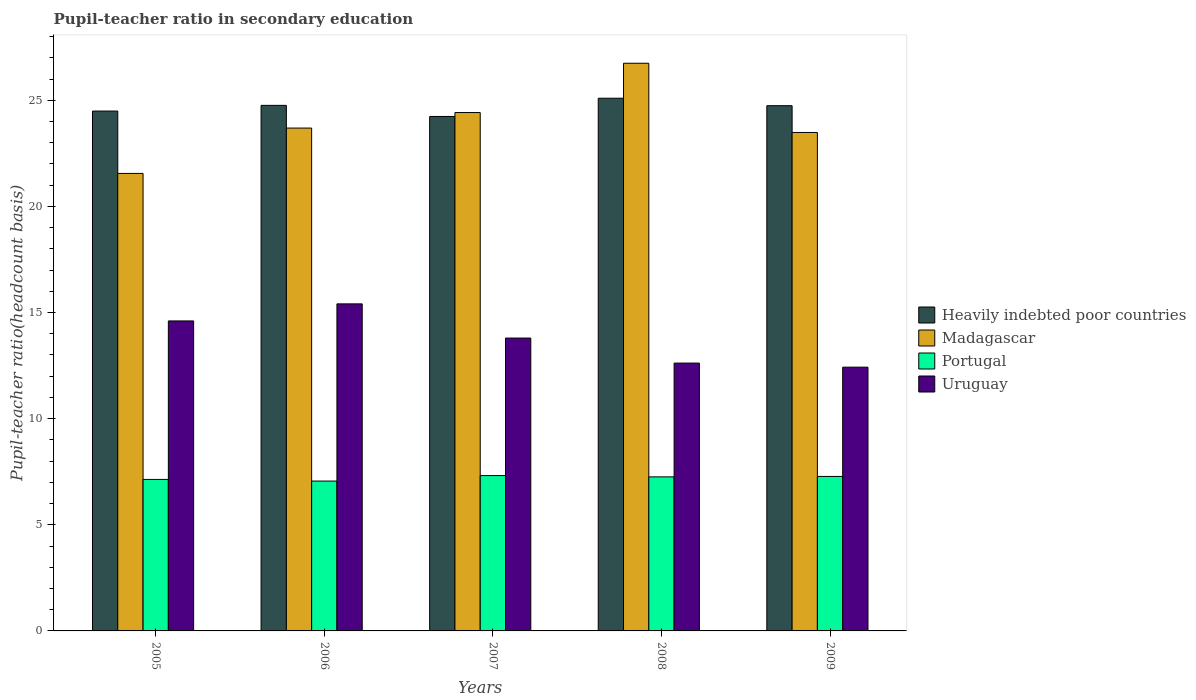How many bars are there on the 4th tick from the left?
Give a very brief answer. 4. How many bars are there on the 3rd tick from the right?
Ensure brevity in your answer.  4. What is the pupil-teacher ratio in secondary education in Madagascar in 2006?
Your response must be concise. 23.69. Across all years, what is the maximum pupil-teacher ratio in secondary education in Portugal?
Provide a short and direct response. 7.32. Across all years, what is the minimum pupil-teacher ratio in secondary education in Portugal?
Give a very brief answer. 7.06. In which year was the pupil-teacher ratio in secondary education in Portugal maximum?
Offer a very short reply. 2007. In which year was the pupil-teacher ratio in secondary education in Portugal minimum?
Your answer should be very brief. 2006. What is the total pupil-teacher ratio in secondary education in Uruguay in the graph?
Provide a short and direct response. 68.86. What is the difference between the pupil-teacher ratio in secondary education in Madagascar in 2007 and that in 2009?
Keep it short and to the point. 0.94. What is the difference between the pupil-teacher ratio in secondary education in Madagascar in 2008 and the pupil-teacher ratio in secondary education in Portugal in 2009?
Offer a very short reply. 19.47. What is the average pupil-teacher ratio in secondary education in Portugal per year?
Provide a succinct answer. 7.21. In the year 2007, what is the difference between the pupil-teacher ratio in secondary education in Uruguay and pupil-teacher ratio in secondary education in Portugal?
Provide a short and direct response. 6.48. What is the ratio of the pupil-teacher ratio in secondary education in Heavily indebted poor countries in 2006 to that in 2009?
Provide a short and direct response. 1. Is the difference between the pupil-teacher ratio in secondary education in Uruguay in 2005 and 2008 greater than the difference between the pupil-teacher ratio in secondary education in Portugal in 2005 and 2008?
Make the answer very short. Yes. What is the difference between the highest and the second highest pupil-teacher ratio in secondary education in Heavily indebted poor countries?
Ensure brevity in your answer.  0.34. What is the difference between the highest and the lowest pupil-teacher ratio in secondary education in Uruguay?
Provide a succinct answer. 2.98. In how many years, is the pupil-teacher ratio in secondary education in Madagascar greater than the average pupil-teacher ratio in secondary education in Madagascar taken over all years?
Make the answer very short. 2. Is it the case that in every year, the sum of the pupil-teacher ratio in secondary education in Portugal and pupil-teacher ratio in secondary education in Madagascar is greater than the sum of pupil-teacher ratio in secondary education in Uruguay and pupil-teacher ratio in secondary education in Heavily indebted poor countries?
Your response must be concise. Yes. What does the 4th bar from the left in 2006 represents?
Give a very brief answer. Uruguay. How many bars are there?
Keep it short and to the point. 20. How many years are there in the graph?
Your answer should be compact. 5. Are the values on the major ticks of Y-axis written in scientific E-notation?
Provide a succinct answer. No. Where does the legend appear in the graph?
Give a very brief answer. Center right. How many legend labels are there?
Make the answer very short. 4. How are the legend labels stacked?
Your answer should be very brief. Vertical. What is the title of the graph?
Your response must be concise. Pupil-teacher ratio in secondary education. What is the label or title of the Y-axis?
Ensure brevity in your answer.  Pupil-teacher ratio(headcount basis). What is the Pupil-teacher ratio(headcount basis) in Heavily indebted poor countries in 2005?
Your answer should be compact. 24.49. What is the Pupil-teacher ratio(headcount basis) of Madagascar in 2005?
Provide a succinct answer. 21.56. What is the Pupil-teacher ratio(headcount basis) of Portugal in 2005?
Provide a succinct answer. 7.14. What is the Pupil-teacher ratio(headcount basis) in Uruguay in 2005?
Provide a short and direct response. 14.6. What is the Pupil-teacher ratio(headcount basis) in Heavily indebted poor countries in 2006?
Make the answer very short. 24.76. What is the Pupil-teacher ratio(headcount basis) of Madagascar in 2006?
Offer a very short reply. 23.69. What is the Pupil-teacher ratio(headcount basis) in Portugal in 2006?
Your response must be concise. 7.06. What is the Pupil-teacher ratio(headcount basis) of Uruguay in 2006?
Make the answer very short. 15.41. What is the Pupil-teacher ratio(headcount basis) of Heavily indebted poor countries in 2007?
Make the answer very short. 24.24. What is the Pupil-teacher ratio(headcount basis) of Madagascar in 2007?
Your answer should be compact. 24.42. What is the Pupil-teacher ratio(headcount basis) in Portugal in 2007?
Offer a very short reply. 7.32. What is the Pupil-teacher ratio(headcount basis) of Uruguay in 2007?
Your answer should be very brief. 13.8. What is the Pupil-teacher ratio(headcount basis) of Heavily indebted poor countries in 2008?
Give a very brief answer. 25.1. What is the Pupil-teacher ratio(headcount basis) in Madagascar in 2008?
Give a very brief answer. 26.74. What is the Pupil-teacher ratio(headcount basis) in Portugal in 2008?
Your answer should be compact. 7.26. What is the Pupil-teacher ratio(headcount basis) in Uruguay in 2008?
Give a very brief answer. 12.62. What is the Pupil-teacher ratio(headcount basis) in Heavily indebted poor countries in 2009?
Provide a short and direct response. 24.75. What is the Pupil-teacher ratio(headcount basis) in Madagascar in 2009?
Keep it short and to the point. 23.48. What is the Pupil-teacher ratio(headcount basis) of Portugal in 2009?
Make the answer very short. 7.28. What is the Pupil-teacher ratio(headcount basis) of Uruguay in 2009?
Your response must be concise. 12.43. Across all years, what is the maximum Pupil-teacher ratio(headcount basis) in Heavily indebted poor countries?
Ensure brevity in your answer.  25.1. Across all years, what is the maximum Pupil-teacher ratio(headcount basis) in Madagascar?
Give a very brief answer. 26.74. Across all years, what is the maximum Pupil-teacher ratio(headcount basis) in Portugal?
Your response must be concise. 7.32. Across all years, what is the maximum Pupil-teacher ratio(headcount basis) in Uruguay?
Your answer should be very brief. 15.41. Across all years, what is the minimum Pupil-teacher ratio(headcount basis) in Heavily indebted poor countries?
Your response must be concise. 24.24. Across all years, what is the minimum Pupil-teacher ratio(headcount basis) of Madagascar?
Ensure brevity in your answer.  21.56. Across all years, what is the minimum Pupil-teacher ratio(headcount basis) of Portugal?
Keep it short and to the point. 7.06. Across all years, what is the minimum Pupil-teacher ratio(headcount basis) in Uruguay?
Give a very brief answer. 12.43. What is the total Pupil-teacher ratio(headcount basis) of Heavily indebted poor countries in the graph?
Your answer should be very brief. 123.33. What is the total Pupil-teacher ratio(headcount basis) in Madagascar in the graph?
Your answer should be very brief. 119.9. What is the total Pupil-teacher ratio(headcount basis) of Portugal in the graph?
Make the answer very short. 36.05. What is the total Pupil-teacher ratio(headcount basis) in Uruguay in the graph?
Keep it short and to the point. 68.86. What is the difference between the Pupil-teacher ratio(headcount basis) of Heavily indebted poor countries in 2005 and that in 2006?
Offer a very short reply. -0.27. What is the difference between the Pupil-teacher ratio(headcount basis) in Madagascar in 2005 and that in 2006?
Ensure brevity in your answer.  -2.14. What is the difference between the Pupil-teacher ratio(headcount basis) in Portugal in 2005 and that in 2006?
Keep it short and to the point. 0.08. What is the difference between the Pupil-teacher ratio(headcount basis) in Uruguay in 2005 and that in 2006?
Make the answer very short. -0.8. What is the difference between the Pupil-teacher ratio(headcount basis) in Heavily indebted poor countries in 2005 and that in 2007?
Offer a very short reply. 0.25. What is the difference between the Pupil-teacher ratio(headcount basis) of Madagascar in 2005 and that in 2007?
Offer a terse response. -2.87. What is the difference between the Pupil-teacher ratio(headcount basis) of Portugal in 2005 and that in 2007?
Your response must be concise. -0.18. What is the difference between the Pupil-teacher ratio(headcount basis) in Uruguay in 2005 and that in 2007?
Provide a succinct answer. 0.81. What is the difference between the Pupil-teacher ratio(headcount basis) of Heavily indebted poor countries in 2005 and that in 2008?
Ensure brevity in your answer.  -0.6. What is the difference between the Pupil-teacher ratio(headcount basis) of Madagascar in 2005 and that in 2008?
Provide a short and direct response. -5.19. What is the difference between the Pupil-teacher ratio(headcount basis) in Portugal in 2005 and that in 2008?
Your answer should be compact. -0.12. What is the difference between the Pupil-teacher ratio(headcount basis) of Uruguay in 2005 and that in 2008?
Your answer should be very brief. 1.99. What is the difference between the Pupil-teacher ratio(headcount basis) of Heavily indebted poor countries in 2005 and that in 2009?
Ensure brevity in your answer.  -0.25. What is the difference between the Pupil-teacher ratio(headcount basis) in Madagascar in 2005 and that in 2009?
Offer a terse response. -1.93. What is the difference between the Pupil-teacher ratio(headcount basis) of Portugal in 2005 and that in 2009?
Your answer should be compact. -0.14. What is the difference between the Pupil-teacher ratio(headcount basis) of Uruguay in 2005 and that in 2009?
Your response must be concise. 2.18. What is the difference between the Pupil-teacher ratio(headcount basis) in Heavily indebted poor countries in 2006 and that in 2007?
Keep it short and to the point. 0.52. What is the difference between the Pupil-teacher ratio(headcount basis) of Madagascar in 2006 and that in 2007?
Provide a succinct answer. -0.73. What is the difference between the Pupil-teacher ratio(headcount basis) in Portugal in 2006 and that in 2007?
Your answer should be compact. -0.26. What is the difference between the Pupil-teacher ratio(headcount basis) in Uruguay in 2006 and that in 2007?
Your answer should be compact. 1.61. What is the difference between the Pupil-teacher ratio(headcount basis) of Heavily indebted poor countries in 2006 and that in 2008?
Offer a terse response. -0.34. What is the difference between the Pupil-teacher ratio(headcount basis) in Madagascar in 2006 and that in 2008?
Keep it short and to the point. -3.05. What is the difference between the Pupil-teacher ratio(headcount basis) in Portugal in 2006 and that in 2008?
Offer a very short reply. -0.2. What is the difference between the Pupil-teacher ratio(headcount basis) in Uruguay in 2006 and that in 2008?
Your answer should be very brief. 2.79. What is the difference between the Pupil-teacher ratio(headcount basis) of Heavily indebted poor countries in 2006 and that in 2009?
Make the answer very short. 0.02. What is the difference between the Pupil-teacher ratio(headcount basis) in Madagascar in 2006 and that in 2009?
Provide a short and direct response. 0.21. What is the difference between the Pupil-teacher ratio(headcount basis) of Portugal in 2006 and that in 2009?
Offer a very short reply. -0.22. What is the difference between the Pupil-teacher ratio(headcount basis) in Uruguay in 2006 and that in 2009?
Your answer should be very brief. 2.98. What is the difference between the Pupil-teacher ratio(headcount basis) in Heavily indebted poor countries in 2007 and that in 2008?
Keep it short and to the point. -0.86. What is the difference between the Pupil-teacher ratio(headcount basis) in Madagascar in 2007 and that in 2008?
Offer a very short reply. -2.32. What is the difference between the Pupil-teacher ratio(headcount basis) in Portugal in 2007 and that in 2008?
Offer a terse response. 0.06. What is the difference between the Pupil-teacher ratio(headcount basis) of Uruguay in 2007 and that in 2008?
Provide a short and direct response. 1.18. What is the difference between the Pupil-teacher ratio(headcount basis) of Heavily indebted poor countries in 2007 and that in 2009?
Your response must be concise. -0.51. What is the difference between the Pupil-teacher ratio(headcount basis) of Madagascar in 2007 and that in 2009?
Provide a short and direct response. 0.94. What is the difference between the Pupil-teacher ratio(headcount basis) of Portugal in 2007 and that in 2009?
Provide a short and direct response. 0.04. What is the difference between the Pupil-teacher ratio(headcount basis) of Uruguay in 2007 and that in 2009?
Make the answer very short. 1.37. What is the difference between the Pupil-teacher ratio(headcount basis) of Heavily indebted poor countries in 2008 and that in 2009?
Your response must be concise. 0.35. What is the difference between the Pupil-teacher ratio(headcount basis) in Madagascar in 2008 and that in 2009?
Your answer should be very brief. 3.26. What is the difference between the Pupil-teacher ratio(headcount basis) of Portugal in 2008 and that in 2009?
Keep it short and to the point. -0.02. What is the difference between the Pupil-teacher ratio(headcount basis) of Uruguay in 2008 and that in 2009?
Your answer should be very brief. 0.19. What is the difference between the Pupil-teacher ratio(headcount basis) of Heavily indebted poor countries in 2005 and the Pupil-teacher ratio(headcount basis) of Madagascar in 2006?
Give a very brief answer. 0.8. What is the difference between the Pupil-teacher ratio(headcount basis) in Heavily indebted poor countries in 2005 and the Pupil-teacher ratio(headcount basis) in Portugal in 2006?
Ensure brevity in your answer.  17.43. What is the difference between the Pupil-teacher ratio(headcount basis) of Heavily indebted poor countries in 2005 and the Pupil-teacher ratio(headcount basis) of Uruguay in 2006?
Ensure brevity in your answer.  9.08. What is the difference between the Pupil-teacher ratio(headcount basis) of Madagascar in 2005 and the Pupil-teacher ratio(headcount basis) of Portugal in 2006?
Make the answer very short. 14.49. What is the difference between the Pupil-teacher ratio(headcount basis) in Madagascar in 2005 and the Pupil-teacher ratio(headcount basis) in Uruguay in 2006?
Ensure brevity in your answer.  6.15. What is the difference between the Pupil-teacher ratio(headcount basis) in Portugal in 2005 and the Pupil-teacher ratio(headcount basis) in Uruguay in 2006?
Provide a short and direct response. -8.27. What is the difference between the Pupil-teacher ratio(headcount basis) in Heavily indebted poor countries in 2005 and the Pupil-teacher ratio(headcount basis) in Madagascar in 2007?
Give a very brief answer. 0.07. What is the difference between the Pupil-teacher ratio(headcount basis) in Heavily indebted poor countries in 2005 and the Pupil-teacher ratio(headcount basis) in Portugal in 2007?
Your answer should be compact. 17.17. What is the difference between the Pupil-teacher ratio(headcount basis) of Heavily indebted poor countries in 2005 and the Pupil-teacher ratio(headcount basis) of Uruguay in 2007?
Ensure brevity in your answer.  10.69. What is the difference between the Pupil-teacher ratio(headcount basis) in Madagascar in 2005 and the Pupil-teacher ratio(headcount basis) in Portugal in 2007?
Make the answer very short. 14.24. What is the difference between the Pupil-teacher ratio(headcount basis) in Madagascar in 2005 and the Pupil-teacher ratio(headcount basis) in Uruguay in 2007?
Offer a very short reply. 7.76. What is the difference between the Pupil-teacher ratio(headcount basis) of Portugal in 2005 and the Pupil-teacher ratio(headcount basis) of Uruguay in 2007?
Offer a terse response. -6.66. What is the difference between the Pupil-teacher ratio(headcount basis) in Heavily indebted poor countries in 2005 and the Pupil-teacher ratio(headcount basis) in Madagascar in 2008?
Your response must be concise. -2.25. What is the difference between the Pupil-teacher ratio(headcount basis) of Heavily indebted poor countries in 2005 and the Pupil-teacher ratio(headcount basis) of Portugal in 2008?
Ensure brevity in your answer.  17.23. What is the difference between the Pupil-teacher ratio(headcount basis) in Heavily indebted poor countries in 2005 and the Pupil-teacher ratio(headcount basis) in Uruguay in 2008?
Keep it short and to the point. 11.87. What is the difference between the Pupil-teacher ratio(headcount basis) of Madagascar in 2005 and the Pupil-teacher ratio(headcount basis) of Portugal in 2008?
Give a very brief answer. 14.3. What is the difference between the Pupil-teacher ratio(headcount basis) of Madagascar in 2005 and the Pupil-teacher ratio(headcount basis) of Uruguay in 2008?
Offer a terse response. 8.94. What is the difference between the Pupil-teacher ratio(headcount basis) in Portugal in 2005 and the Pupil-teacher ratio(headcount basis) in Uruguay in 2008?
Provide a short and direct response. -5.48. What is the difference between the Pupil-teacher ratio(headcount basis) in Heavily indebted poor countries in 2005 and the Pupil-teacher ratio(headcount basis) in Madagascar in 2009?
Provide a short and direct response. 1.01. What is the difference between the Pupil-teacher ratio(headcount basis) of Heavily indebted poor countries in 2005 and the Pupil-teacher ratio(headcount basis) of Portugal in 2009?
Your answer should be very brief. 17.21. What is the difference between the Pupil-teacher ratio(headcount basis) in Heavily indebted poor countries in 2005 and the Pupil-teacher ratio(headcount basis) in Uruguay in 2009?
Make the answer very short. 12.07. What is the difference between the Pupil-teacher ratio(headcount basis) in Madagascar in 2005 and the Pupil-teacher ratio(headcount basis) in Portugal in 2009?
Give a very brief answer. 14.28. What is the difference between the Pupil-teacher ratio(headcount basis) in Madagascar in 2005 and the Pupil-teacher ratio(headcount basis) in Uruguay in 2009?
Provide a short and direct response. 9.13. What is the difference between the Pupil-teacher ratio(headcount basis) of Portugal in 2005 and the Pupil-teacher ratio(headcount basis) of Uruguay in 2009?
Offer a very short reply. -5.29. What is the difference between the Pupil-teacher ratio(headcount basis) of Heavily indebted poor countries in 2006 and the Pupil-teacher ratio(headcount basis) of Madagascar in 2007?
Give a very brief answer. 0.34. What is the difference between the Pupil-teacher ratio(headcount basis) in Heavily indebted poor countries in 2006 and the Pupil-teacher ratio(headcount basis) in Portugal in 2007?
Your answer should be very brief. 17.44. What is the difference between the Pupil-teacher ratio(headcount basis) of Heavily indebted poor countries in 2006 and the Pupil-teacher ratio(headcount basis) of Uruguay in 2007?
Your response must be concise. 10.96. What is the difference between the Pupil-teacher ratio(headcount basis) in Madagascar in 2006 and the Pupil-teacher ratio(headcount basis) in Portugal in 2007?
Provide a succinct answer. 16.37. What is the difference between the Pupil-teacher ratio(headcount basis) of Madagascar in 2006 and the Pupil-teacher ratio(headcount basis) of Uruguay in 2007?
Offer a very short reply. 9.89. What is the difference between the Pupil-teacher ratio(headcount basis) in Portugal in 2006 and the Pupil-teacher ratio(headcount basis) in Uruguay in 2007?
Provide a short and direct response. -6.74. What is the difference between the Pupil-teacher ratio(headcount basis) in Heavily indebted poor countries in 2006 and the Pupil-teacher ratio(headcount basis) in Madagascar in 2008?
Your answer should be compact. -1.98. What is the difference between the Pupil-teacher ratio(headcount basis) of Heavily indebted poor countries in 2006 and the Pupil-teacher ratio(headcount basis) of Portugal in 2008?
Provide a short and direct response. 17.5. What is the difference between the Pupil-teacher ratio(headcount basis) of Heavily indebted poor countries in 2006 and the Pupil-teacher ratio(headcount basis) of Uruguay in 2008?
Offer a terse response. 12.14. What is the difference between the Pupil-teacher ratio(headcount basis) in Madagascar in 2006 and the Pupil-teacher ratio(headcount basis) in Portugal in 2008?
Give a very brief answer. 16.43. What is the difference between the Pupil-teacher ratio(headcount basis) in Madagascar in 2006 and the Pupil-teacher ratio(headcount basis) in Uruguay in 2008?
Ensure brevity in your answer.  11.07. What is the difference between the Pupil-teacher ratio(headcount basis) of Portugal in 2006 and the Pupil-teacher ratio(headcount basis) of Uruguay in 2008?
Ensure brevity in your answer.  -5.56. What is the difference between the Pupil-teacher ratio(headcount basis) of Heavily indebted poor countries in 2006 and the Pupil-teacher ratio(headcount basis) of Madagascar in 2009?
Provide a succinct answer. 1.28. What is the difference between the Pupil-teacher ratio(headcount basis) of Heavily indebted poor countries in 2006 and the Pupil-teacher ratio(headcount basis) of Portugal in 2009?
Your response must be concise. 17.48. What is the difference between the Pupil-teacher ratio(headcount basis) in Heavily indebted poor countries in 2006 and the Pupil-teacher ratio(headcount basis) in Uruguay in 2009?
Give a very brief answer. 12.33. What is the difference between the Pupil-teacher ratio(headcount basis) of Madagascar in 2006 and the Pupil-teacher ratio(headcount basis) of Portugal in 2009?
Your answer should be very brief. 16.41. What is the difference between the Pupil-teacher ratio(headcount basis) of Madagascar in 2006 and the Pupil-teacher ratio(headcount basis) of Uruguay in 2009?
Offer a terse response. 11.27. What is the difference between the Pupil-teacher ratio(headcount basis) in Portugal in 2006 and the Pupil-teacher ratio(headcount basis) in Uruguay in 2009?
Offer a very short reply. -5.37. What is the difference between the Pupil-teacher ratio(headcount basis) in Heavily indebted poor countries in 2007 and the Pupil-teacher ratio(headcount basis) in Madagascar in 2008?
Your answer should be very brief. -2.51. What is the difference between the Pupil-teacher ratio(headcount basis) in Heavily indebted poor countries in 2007 and the Pupil-teacher ratio(headcount basis) in Portugal in 2008?
Provide a short and direct response. 16.98. What is the difference between the Pupil-teacher ratio(headcount basis) of Heavily indebted poor countries in 2007 and the Pupil-teacher ratio(headcount basis) of Uruguay in 2008?
Keep it short and to the point. 11.62. What is the difference between the Pupil-teacher ratio(headcount basis) in Madagascar in 2007 and the Pupil-teacher ratio(headcount basis) in Portugal in 2008?
Offer a terse response. 17.16. What is the difference between the Pupil-teacher ratio(headcount basis) of Madagascar in 2007 and the Pupil-teacher ratio(headcount basis) of Uruguay in 2008?
Your answer should be very brief. 11.8. What is the difference between the Pupil-teacher ratio(headcount basis) of Portugal in 2007 and the Pupil-teacher ratio(headcount basis) of Uruguay in 2008?
Your response must be concise. -5.3. What is the difference between the Pupil-teacher ratio(headcount basis) of Heavily indebted poor countries in 2007 and the Pupil-teacher ratio(headcount basis) of Madagascar in 2009?
Provide a succinct answer. 0.75. What is the difference between the Pupil-teacher ratio(headcount basis) in Heavily indebted poor countries in 2007 and the Pupil-teacher ratio(headcount basis) in Portugal in 2009?
Give a very brief answer. 16.96. What is the difference between the Pupil-teacher ratio(headcount basis) in Heavily indebted poor countries in 2007 and the Pupil-teacher ratio(headcount basis) in Uruguay in 2009?
Offer a very short reply. 11.81. What is the difference between the Pupil-teacher ratio(headcount basis) in Madagascar in 2007 and the Pupil-teacher ratio(headcount basis) in Portugal in 2009?
Your response must be concise. 17.15. What is the difference between the Pupil-teacher ratio(headcount basis) of Madagascar in 2007 and the Pupil-teacher ratio(headcount basis) of Uruguay in 2009?
Keep it short and to the point. 12. What is the difference between the Pupil-teacher ratio(headcount basis) in Portugal in 2007 and the Pupil-teacher ratio(headcount basis) in Uruguay in 2009?
Make the answer very short. -5.11. What is the difference between the Pupil-teacher ratio(headcount basis) of Heavily indebted poor countries in 2008 and the Pupil-teacher ratio(headcount basis) of Madagascar in 2009?
Provide a succinct answer. 1.61. What is the difference between the Pupil-teacher ratio(headcount basis) in Heavily indebted poor countries in 2008 and the Pupil-teacher ratio(headcount basis) in Portugal in 2009?
Ensure brevity in your answer.  17.82. What is the difference between the Pupil-teacher ratio(headcount basis) of Heavily indebted poor countries in 2008 and the Pupil-teacher ratio(headcount basis) of Uruguay in 2009?
Your response must be concise. 12.67. What is the difference between the Pupil-teacher ratio(headcount basis) of Madagascar in 2008 and the Pupil-teacher ratio(headcount basis) of Portugal in 2009?
Offer a very short reply. 19.47. What is the difference between the Pupil-teacher ratio(headcount basis) in Madagascar in 2008 and the Pupil-teacher ratio(headcount basis) in Uruguay in 2009?
Your answer should be compact. 14.32. What is the difference between the Pupil-teacher ratio(headcount basis) in Portugal in 2008 and the Pupil-teacher ratio(headcount basis) in Uruguay in 2009?
Your answer should be compact. -5.17. What is the average Pupil-teacher ratio(headcount basis) in Heavily indebted poor countries per year?
Offer a terse response. 24.67. What is the average Pupil-teacher ratio(headcount basis) of Madagascar per year?
Your answer should be compact. 23.98. What is the average Pupil-teacher ratio(headcount basis) of Portugal per year?
Ensure brevity in your answer.  7.21. What is the average Pupil-teacher ratio(headcount basis) of Uruguay per year?
Offer a terse response. 13.77. In the year 2005, what is the difference between the Pupil-teacher ratio(headcount basis) in Heavily indebted poor countries and Pupil-teacher ratio(headcount basis) in Madagascar?
Your answer should be compact. 2.94. In the year 2005, what is the difference between the Pupil-teacher ratio(headcount basis) in Heavily indebted poor countries and Pupil-teacher ratio(headcount basis) in Portugal?
Provide a short and direct response. 17.36. In the year 2005, what is the difference between the Pupil-teacher ratio(headcount basis) in Heavily indebted poor countries and Pupil-teacher ratio(headcount basis) in Uruguay?
Offer a terse response. 9.89. In the year 2005, what is the difference between the Pupil-teacher ratio(headcount basis) in Madagascar and Pupil-teacher ratio(headcount basis) in Portugal?
Offer a terse response. 14.42. In the year 2005, what is the difference between the Pupil-teacher ratio(headcount basis) of Madagascar and Pupil-teacher ratio(headcount basis) of Uruguay?
Your answer should be very brief. 6.95. In the year 2005, what is the difference between the Pupil-teacher ratio(headcount basis) in Portugal and Pupil-teacher ratio(headcount basis) in Uruguay?
Your response must be concise. -7.47. In the year 2006, what is the difference between the Pupil-teacher ratio(headcount basis) in Heavily indebted poor countries and Pupil-teacher ratio(headcount basis) in Madagascar?
Keep it short and to the point. 1.07. In the year 2006, what is the difference between the Pupil-teacher ratio(headcount basis) in Heavily indebted poor countries and Pupil-teacher ratio(headcount basis) in Portugal?
Your response must be concise. 17.7. In the year 2006, what is the difference between the Pupil-teacher ratio(headcount basis) of Heavily indebted poor countries and Pupil-teacher ratio(headcount basis) of Uruguay?
Provide a short and direct response. 9.35. In the year 2006, what is the difference between the Pupil-teacher ratio(headcount basis) of Madagascar and Pupil-teacher ratio(headcount basis) of Portugal?
Give a very brief answer. 16.63. In the year 2006, what is the difference between the Pupil-teacher ratio(headcount basis) in Madagascar and Pupil-teacher ratio(headcount basis) in Uruguay?
Keep it short and to the point. 8.28. In the year 2006, what is the difference between the Pupil-teacher ratio(headcount basis) of Portugal and Pupil-teacher ratio(headcount basis) of Uruguay?
Provide a short and direct response. -8.35. In the year 2007, what is the difference between the Pupil-teacher ratio(headcount basis) in Heavily indebted poor countries and Pupil-teacher ratio(headcount basis) in Madagascar?
Make the answer very short. -0.18. In the year 2007, what is the difference between the Pupil-teacher ratio(headcount basis) of Heavily indebted poor countries and Pupil-teacher ratio(headcount basis) of Portugal?
Provide a succinct answer. 16.92. In the year 2007, what is the difference between the Pupil-teacher ratio(headcount basis) of Heavily indebted poor countries and Pupil-teacher ratio(headcount basis) of Uruguay?
Your response must be concise. 10.44. In the year 2007, what is the difference between the Pupil-teacher ratio(headcount basis) in Madagascar and Pupil-teacher ratio(headcount basis) in Portugal?
Give a very brief answer. 17.11. In the year 2007, what is the difference between the Pupil-teacher ratio(headcount basis) of Madagascar and Pupil-teacher ratio(headcount basis) of Uruguay?
Your answer should be compact. 10.63. In the year 2007, what is the difference between the Pupil-teacher ratio(headcount basis) of Portugal and Pupil-teacher ratio(headcount basis) of Uruguay?
Provide a succinct answer. -6.48. In the year 2008, what is the difference between the Pupil-teacher ratio(headcount basis) of Heavily indebted poor countries and Pupil-teacher ratio(headcount basis) of Madagascar?
Offer a terse response. -1.65. In the year 2008, what is the difference between the Pupil-teacher ratio(headcount basis) of Heavily indebted poor countries and Pupil-teacher ratio(headcount basis) of Portugal?
Provide a short and direct response. 17.84. In the year 2008, what is the difference between the Pupil-teacher ratio(headcount basis) in Heavily indebted poor countries and Pupil-teacher ratio(headcount basis) in Uruguay?
Your answer should be compact. 12.48. In the year 2008, what is the difference between the Pupil-teacher ratio(headcount basis) in Madagascar and Pupil-teacher ratio(headcount basis) in Portugal?
Give a very brief answer. 19.49. In the year 2008, what is the difference between the Pupil-teacher ratio(headcount basis) of Madagascar and Pupil-teacher ratio(headcount basis) of Uruguay?
Ensure brevity in your answer.  14.13. In the year 2008, what is the difference between the Pupil-teacher ratio(headcount basis) in Portugal and Pupil-teacher ratio(headcount basis) in Uruguay?
Give a very brief answer. -5.36. In the year 2009, what is the difference between the Pupil-teacher ratio(headcount basis) in Heavily indebted poor countries and Pupil-teacher ratio(headcount basis) in Madagascar?
Give a very brief answer. 1.26. In the year 2009, what is the difference between the Pupil-teacher ratio(headcount basis) of Heavily indebted poor countries and Pupil-teacher ratio(headcount basis) of Portugal?
Give a very brief answer. 17.47. In the year 2009, what is the difference between the Pupil-teacher ratio(headcount basis) of Heavily indebted poor countries and Pupil-teacher ratio(headcount basis) of Uruguay?
Offer a very short reply. 12.32. In the year 2009, what is the difference between the Pupil-teacher ratio(headcount basis) of Madagascar and Pupil-teacher ratio(headcount basis) of Portugal?
Keep it short and to the point. 16.21. In the year 2009, what is the difference between the Pupil-teacher ratio(headcount basis) in Madagascar and Pupil-teacher ratio(headcount basis) in Uruguay?
Provide a succinct answer. 11.06. In the year 2009, what is the difference between the Pupil-teacher ratio(headcount basis) in Portugal and Pupil-teacher ratio(headcount basis) in Uruguay?
Make the answer very short. -5.15. What is the ratio of the Pupil-teacher ratio(headcount basis) in Madagascar in 2005 to that in 2006?
Offer a terse response. 0.91. What is the ratio of the Pupil-teacher ratio(headcount basis) in Portugal in 2005 to that in 2006?
Keep it short and to the point. 1.01. What is the ratio of the Pupil-teacher ratio(headcount basis) in Uruguay in 2005 to that in 2006?
Offer a very short reply. 0.95. What is the ratio of the Pupil-teacher ratio(headcount basis) in Heavily indebted poor countries in 2005 to that in 2007?
Keep it short and to the point. 1.01. What is the ratio of the Pupil-teacher ratio(headcount basis) of Madagascar in 2005 to that in 2007?
Your answer should be compact. 0.88. What is the ratio of the Pupil-teacher ratio(headcount basis) of Portugal in 2005 to that in 2007?
Provide a short and direct response. 0.98. What is the ratio of the Pupil-teacher ratio(headcount basis) of Uruguay in 2005 to that in 2007?
Provide a short and direct response. 1.06. What is the ratio of the Pupil-teacher ratio(headcount basis) in Heavily indebted poor countries in 2005 to that in 2008?
Your answer should be compact. 0.98. What is the ratio of the Pupil-teacher ratio(headcount basis) of Madagascar in 2005 to that in 2008?
Your response must be concise. 0.81. What is the ratio of the Pupil-teacher ratio(headcount basis) of Portugal in 2005 to that in 2008?
Make the answer very short. 0.98. What is the ratio of the Pupil-teacher ratio(headcount basis) in Uruguay in 2005 to that in 2008?
Your answer should be very brief. 1.16. What is the ratio of the Pupil-teacher ratio(headcount basis) of Heavily indebted poor countries in 2005 to that in 2009?
Your answer should be very brief. 0.99. What is the ratio of the Pupil-teacher ratio(headcount basis) of Madagascar in 2005 to that in 2009?
Your answer should be compact. 0.92. What is the ratio of the Pupil-teacher ratio(headcount basis) of Portugal in 2005 to that in 2009?
Provide a succinct answer. 0.98. What is the ratio of the Pupil-teacher ratio(headcount basis) of Uruguay in 2005 to that in 2009?
Keep it short and to the point. 1.18. What is the ratio of the Pupil-teacher ratio(headcount basis) of Heavily indebted poor countries in 2006 to that in 2007?
Make the answer very short. 1.02. What is the ratio of the Pupil-teacher ratio(headcount basis) of Portugal in 2006 to that in 2007?
Keep it short and to the point. 0.96. What is the ratio of the Pupil-teacher ratio(headcount basis) in Uruguay in 2006 to that in 2007?
Your answer should be compact. 1.12. What is the ratio of the Pupil-teacher ratio(headcount basis) in Heavily indebted poor countries in 2006 to that in 2008?
Offer a terse response. 0.99. What is the ratio of the Pupil-teacher ratio(headcount basis) in Madagascar in 2006 to that in 2008?
Provide a short and direct response. 0.89. What is the ratio of the Pupil-teacher ratio(headcount basis) in Portugal in 2006 to that in 2008?
Your answer should be compact. 0.97. What is the ratio of the Pupil-teacher ratio(headcount basis) in Uruguay in 2006 to that in 2008?
Offer a terse response. 1.22. What is the ratio of the Pupil-teacher ratio(headcount basis) of Heavily indebted poor countries in 2006 to that in 2009?
Keep it short and to the point. 1. What is the ratio of the Pupil-teacher ratio(headcount basis) of Madagascar in 2006 to that in 2009?
Make the answer very short. 1.01. What is the ratio of the Pupil-teacher ratio(headcount basis) of Portugal in 2006 to that in 2009?
Make the answer very short. 0.97. What is the ratio of the Pupil-teacher ratio(headcount basis) in Uruguay in 2006 to that in 2009?
Offer a very short reply. 1.24. What is the ratio of the Pupil-teacher ratio(headcount basis) in Heavily indebted poor countries in 2007 to that in 2008?
Keep it short and to the point. 0.97. What is the ratio of the Pupil-teacher ratio(headcount basis) of Madagascar in 2007 to that in 2008?
Your answer should be compact. 0.91. What is the ratio of the Pupil-teacher ratio(headcount basis) in Portugal in 2007 to that in 2008?
Provide a short and direct response. 1.01. What is the ratio of the Pupil-teacher ratio(headcount basis) of Uruguay in 2007 to that in 2008?
Your answer should be very brief. 1.09. What is the ratio of the Pupil-teacher ratio(headcount basis) in Heavily indebted poor countries in 2007 to that in 2009?
Offer a terse response. 0.98. What is the ratio of the Pupil-teacher ratio(headcount basis) of Madagascar in 2007 to that in 2009?
Provide a short and direct response. 1.04. What is the ratio of the Pupil-teacher ratio(headcount basis) in Portugal in 2007 to that in 2009?
Provide a short and direct response. 1.01. What is the ratio of the Pupil-teacher ratio(headcount basis) of Uruguay in 2007 to that in 2009?
Make the answer very short. 1.11. What is the ratio of the Pupil-teacher ratio(headcount basis) of Heavily indebted poor countries in 2008 to that in 2009?
Your answer should be compact. 1.01. What is the ratio of the Pupil-teacher ratio(headcount basis) in Madagascar in 2008 to that in 2009?
Give a very brief answer. 1.14. What is the ratio of the Pupil-teacher ratio(headcount basis) of Portugal in 2008 to that in 2009?
Your answer should be compact. 1. What is the ratio of the Pupil-teacher ratio(headcount basis) of Uruguay in 2008 to that in 2009?
Ensure brevity in your answer.  1.02. What is the difference between the highest and the second highest Pupil-teacher ratio(headcount basis) of Heavily indebted poor countries?
Give a very brief answer. 0.34. What is the difference between the highest and the second highest Pupil-teacher ratio(headcount basis) of Madagascar?
Your answer should be very brief. 2.32. What is the difference between the highest and the second highest Pupil-teacher ratio(headcount basis) in Portugal?
Provide a short and direct response. 0.04. What is the difference between the highest and the second highest Pupil-teacher ratio(headcount basis) of Uruguay?
Your answer should be very brief. 0.8. What is the difference between the highest and the lowest Pupil-teacher ratio(headcount basis) in Heavily indebted poor countries?
Provide a succinct answer. 0.86. What is the difference between the highest and the lowest Pupil-teacher ratio(headcount basis) of Madagascar?
Give a very brief answer. 5.19. What is the difference between the highest and the lowest Pupil-teacher ratio(headcount basis) in Portugal?
Your answer should be very brief. 0.26. What is the difference between the highest and the lowest Pupil-teacher ratio(headcount basis) in Uruguay?
Give a very brief answer. 2.98. 